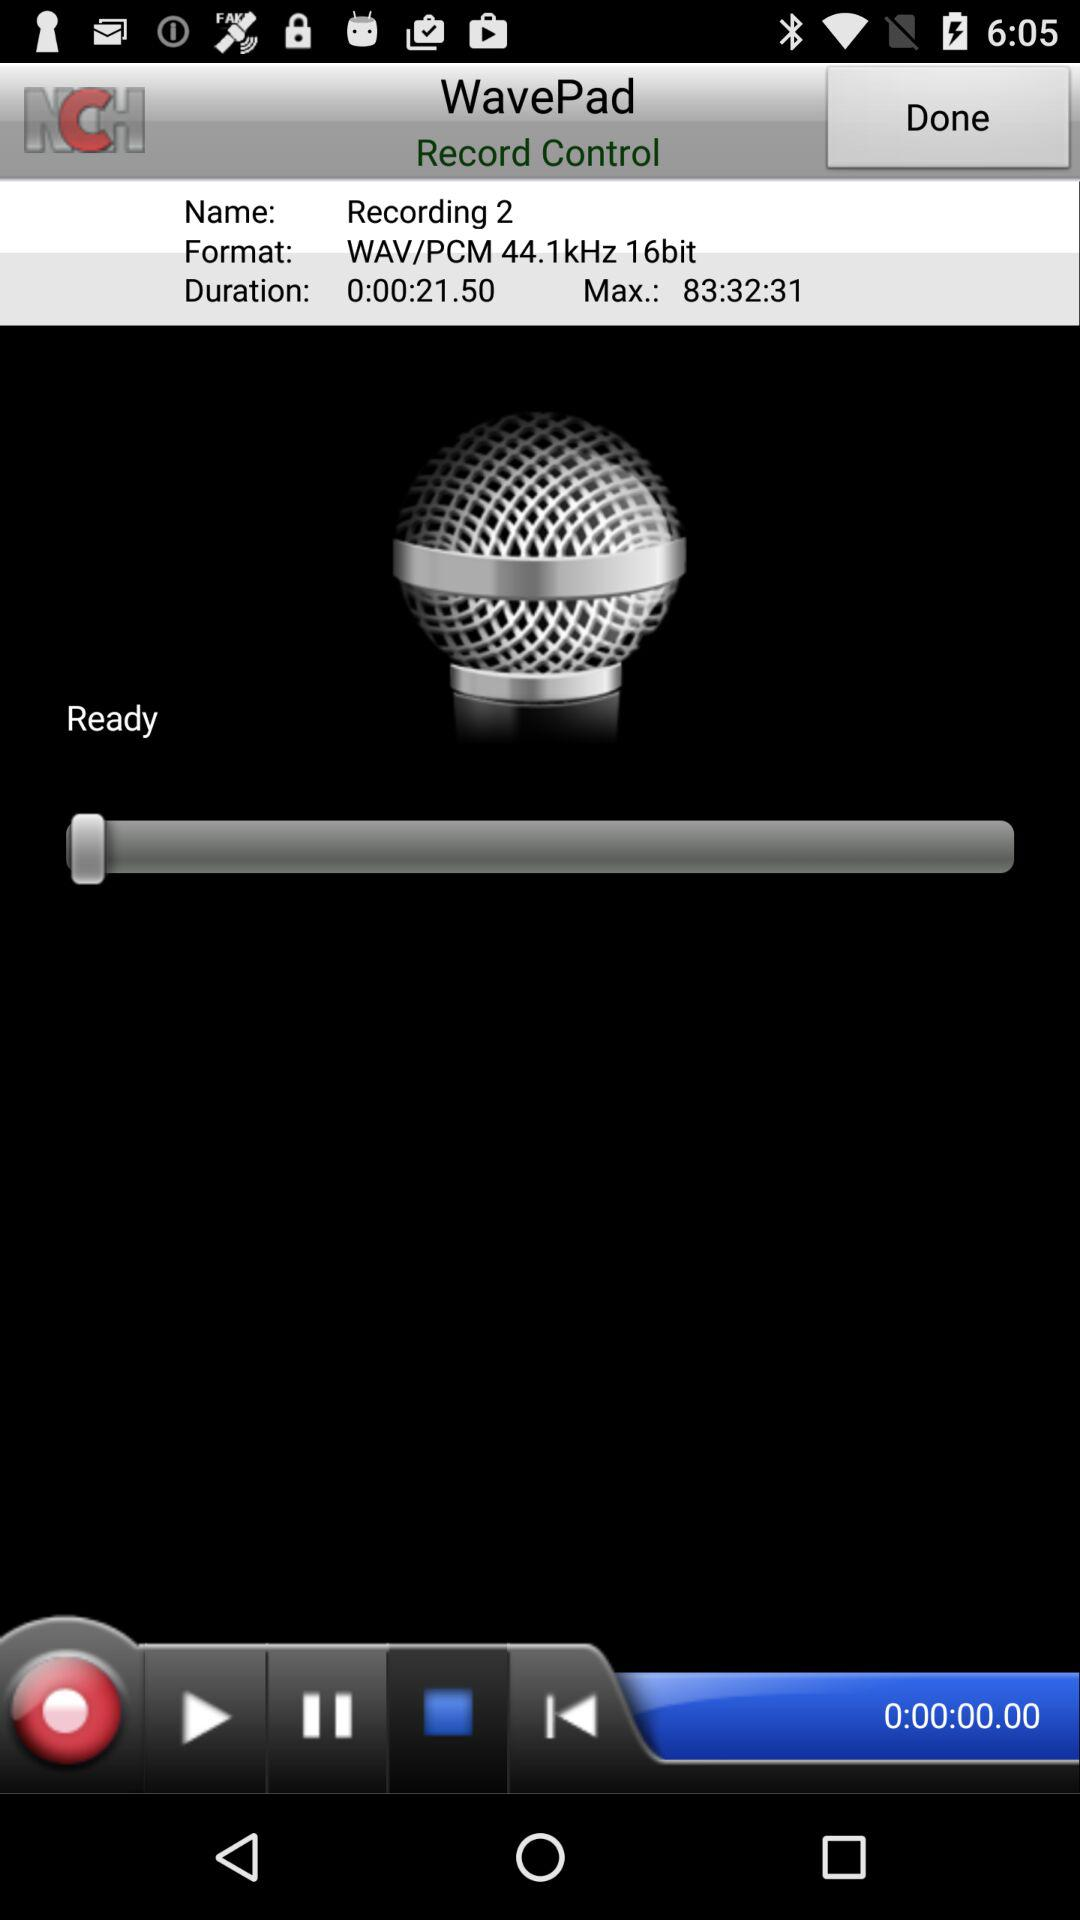How long is recording 1?
When the provided information is insufficient, respond with <no answer>. <no answer> 